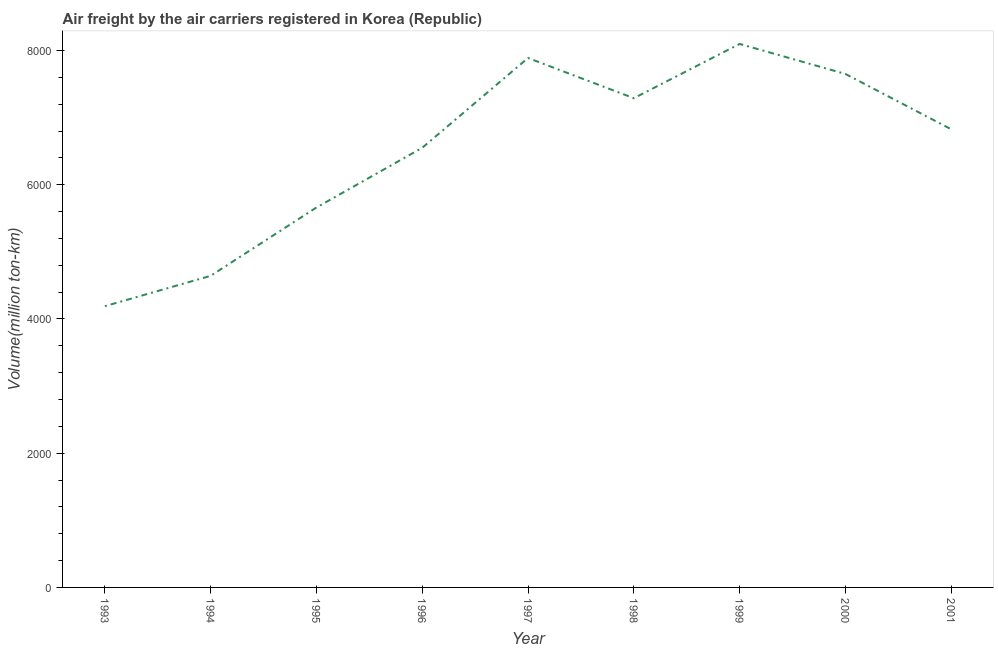What is the air freight in 1993?
Your answer should be compact. 4191. Across all years, what is the maximum air freight?
Keep it short and to the point. 8098.4. Across all years, what is the minimum air freight?
Offer a terse response. 4191. In which year was the air freight minimum?
Offer a very short reply. 1993. What is the sum of the air freight?
Provide a succinct answer. 5.88e+04. What is the difference between the air freight in 1997 and 1998?
Your answer should be very brief. 599.2. What is the average air freight per year?
Your response must be concise. 6533.62. What is the median air freight?
Your response must be concise. 6827.18. In how many years, is the air freight greater than 1200 million ton-km?
Give a very brief answer. 9. Do a majority of the years between 1993 and 2000 (inclusive) have air freight greater than 7200 million ton-km?
Your answer should be very brief. No. What is the ratio of the air freight in 1993 to that in 1996?
Make the answer very short. 0.64. What is the difference between the highest and the second highest air freight?
Provide a succinct answer. 209.2. Is the sum of the air freight in 1998 and 2000 greater than the maximum air freight across all years?
Your answer should be very brief. Yes. What is the difference between the highest and the lowest air freight?
Keep it short and to the point. 3907.4. In how many years, is the air freight greater than the average air freight taken over all years?
Your answer should be compact. 6. Does the air freight monotonically increase over the years?
Your answer should be very brief. No. How many years are there in the graph?
Provide a succinct answer. 9. What is the difference between two consecutive major ticks on the Y-axis?
Make the answer very short. 2000. What is the title of the graph?
Your response must be concise. Air freight by the air carriers registered in Korea (Republic). What is the label or title of the X-axis?
Make the answer very short. Year. What is the label or title of the Y-axis?
Offer a very short reply. Volume(million ton-km). What is the Volume(million ton-km) in 1993?
Give a very brief answer. 4191. What is the Volume(million ton-km) of 1994?
Your answer should be very brief. 4643.3. What is the Volume(million ton-km) in 1995?
Keep it short and to the point. 5661.3. What is the Volume(million ton-km) of 1996?
Offer a terse response. 6550.9. What is the Volume(million ton-km) in 1997?
Provide a succinct answer. 7889.2. What is the Volume(million ton-km) in 1998?
Make the answer very short. 7290. What is the Volume(million ton-km) in 1999?
Your answer should be very brief. 8098.4. What is the Volume(million ton-km) in 2000?
Make the answer very short. 7651.34. What is the Volume(million ton-km) in 2001?
Provide a short and direct response. 6827.18. What is the difference between the Volume(million ton-km) in 1993 and 1994?
Your response must be concise. -452.3. What is the difference between the Volume(million ton-km) in 1993 and 1995?
Your answer should be very brief. -1470.3. What is the difference between the Volume(million ton-km) in 1993 and 1996?
Provide a short and direct response. -2359.9. What is the difference between the Volume(million ton-km) in 1993 and 1997?
Your answer should be very brief. -3698.2. What is the difference between the Volume(million ton-km) in 1993 and 1998?
Give a very brief answer. -3099. What is the difference between the Volume(million ton-km) in 1993 and 1999?
Make the answer very short. -3907.4. What is the difference between the Volume(million ton-km) in 1993 and 2000?
Offer a very short reply. -3460.34. What is the difference between the Volume(million ton-km) in 1993 and 2001?
Make the answer very short. -2636.18. What is the difference between the Volume(million ton-km) in 1994 and 1995?
Keep it short and to the point. -1018. What is the difference between the Volume(million ton-km) in 1994 and 1996?
Offer a terse response. -1907.6. What is the difference between the Volume(million ton-km) in 1994 and 1997?
Your answer should be compact. -3245.9. What is the difference between the Volume(million ton-km) in 1994 and 1998?
Your answer should be very brief. -2646.7. What is the difference between the Volume(million ton-km) in 1994 and 1999?
Ensure brevity in your answer.  -3455.1. What is the difference between the Volume(million ton-km) in 1994 and 2000?
Offer a terse response. -3008.04. What is the difference between the Volume(million ton-km) in 1994 and 2001?
Ensure brevity in your answer.  -2183.88. What is the difference between the Volume(million ton-km) in 1995 and 1996?
Your response must be concise. -889.6. What is the difference between the Volume(million ton-km) in 1995 and 1997?
Give a very brief answer. -2227.9. What is the difference between the Volume(million ton-km) in 1995 and 1998?
Provide a succinct answer. -1628.7. What is the difference between the Volume(million ton-km) in 1995 and 1999?
Offer a terse response. -2437.1. What is the difference between the Volume(million ton-km) in 1995 and 2000?
Provide a succinct answer. -1990.04. What is the difference between the Volume(million ton-km) in 1995 and 2001?
Keep it short and to the point. -1165.88. What is the difference between the Volume(million ton-km) in 1996 and 1997?
Make the answer very short. -1338.3. What is the difference between the Volume(million ton-km) in 1996 and 1998?
Your answer should be compact. -739.1. What is the difference between the Volume(million ton-km) in 1996 and 1999?
Offer a terse response. -1547.5. What is the difference between the Volume(million ton-km) in 1996 and 2000?
Provide a short and direct response. -1100.44. What is the difference between the Volume(million ton-km) in 1996 and 2001?
Make the answer very short. -276.28. What is the difference between the Volume(million ton-km) in 1997 and 1998?
Make the answer very short. 599.2. What is the difference between the Volume(million ton-km) in 1997 and 1999?
Make the answer very short. -209.2. What is the difference between the Volume(million ton-km) in 1997 and 2000?
Offer a terse response. 237.86. What is the difference between the Volume(million ton-km) in 1997 and 2001?
Provide a short and direct response. 1062.02. What is the difference between the Volume(million ton-km) in 1998 and 1999?
Make the answer very short. -808.4. What is the difference between the Volume(million ton-km) in 1998 and 2000?
Offer a terse response. -361.34. What is the difference between the Volume(million ton-km) in 1998 and 2001?
Offer a very short reply. 462.82. What is the difference between the Volume(million ton-km) in 1999 and 2000?
Your response must be concise. 447.06. What is the difference between the Volume(million ton-km) in 1999 and 2001?
Provide a succinct answer. 1271.22. What is the difference between the Volume(million ton-km) in 2000 and 2001?
Offer a terse response. 824.16. What is the ratio of the Volume(million ton-km) in 1993 to that in 1994?
Your response must be concise. 0.9. What is the ratio of the Volume(million ton-km) in 1993 to that in 1995?
Provide a succinct answer. 0.74. What is the ratio of the Volume(million ton-km) in 1993 to that in 1996?
Offer a very short reply. 0.64. What is the ratio of the Volume(million ton-km) in 1993 to that in 1997?
Your answer should be compact. 0.53. What is the ratio of the Volume(million ton-km) in 1993 to that in 1998?
Make the answer very short. 0.57. What is the ratio of the Volume(million ton-km) in 1993 to that in 1999?
Ensure brevity in your answer.  0.52. What is the ratio of the Volume(million ton-km) in 1993 to that in 2000?
Keep it short and to the point. 0.55. What is the ratio of the Volume(million ton-km) in 1993 to that in 2001?
Provide a succinct answer. 0.61. What is the ratio of the Volume(million ton-km) in 1994 to that in 1995?
Provide a short and direct response. 0.82. What is the ratio of the Volume(million ton-km) in 1994 to that in 1996?
Provide a short and direct response. 0.71. What is the ratio of the Volume(million ton-km) in 1994 to that in 1997?
Provide a succinct answer. 0.59. What is the ratio of the Volume(million ton-km) in 1994 to that in 1998?
Ensure brevity in your answer.  0.64. What is the ratio of the Volume(million ton-km) in 1994 to that in 1999?
Your answer should be very brief. 0.57. What is the ratio of the Volume(million ton-km) in 1994 to that in 2000?
Your answer should be very brief. 0.61. What is the ratio of the Volume(million ton-km) in 1994 to that in 2001?
Your answer should be compact. 0.68. What is the ratio of the Volume(million ton-km) in 1995 to that in 1996?
Offer a terse response. 0.86. What is the ratio of the Volume(million ton-km) in 1995 to that in 1997?
Provide a short and direct response. 0.72. What is the ratio of the Volume(million ton-km) in 1995 to that in 1998?
Offer a very short reply. 0.78. What is the ratio of the Volume(million ton-km) in 1995 to that in 1999?
Keep it short and to the point. 0.7. What is the ratio of the Volume(million ton-km) in 1995 to that in 2000?
Provide a succinct answer. 0.74. What is the ratio of the Volume(million ton-km) in 1995 to that in 2001?
Ensure brevity in your answer.  0.83. What is the ratio of the Volume(million ton-km) in 1996 to that in 1997?
Keep it short and to the point. 0.83. What is the ratio of the Volume(million ton-km) in 1996 to that in 1998?
Offer a terse response. 0.9. What is the ratio of the Volume(million ton-km) in 1996 to that in 1999?
Your response must be concise. 0.81. What is the ratio of the Volume(million ton-km) in 1996 to that in 2000?
Your answer should be very brief. 0.86. What is the ratio of the Volume(million ton-km) in 1996 to that in 2001?
Give a very brief answer. 0.96. What is the ratio of the Volume(million ton-km) in 1997 to that in 1998?
Your response must be concise. 1.08. What is the ratio of the Volume(million ton-km) in 1997 to that in 2000?
Make the answer very short. 1.03. What is the ratio of the Volume(million ton-km) in 1997 to that in 2001?
Make the answer very short. 1.16. What is the ratio of the Volume(million ton-km) in 1998 to that in 2000?
Ensure brevity in your answer.  0.95. What is the ratio of the Volume(million ton-km) in 1998 to that in 2001?
Offer a terse response. 1.07. What is the ratio of the Volume(million ton-km) in 1999 to that in 2000?
Make the answer very short. 1.06. What is the ratio of the Volume(million ton-km) in 1999 to that in 2001?
Your response must be concise. 1.19. What is the ratio of the Volume(million ton-km) in 2000 to that in 2001?
Your answer should be very brief. 1.12. 